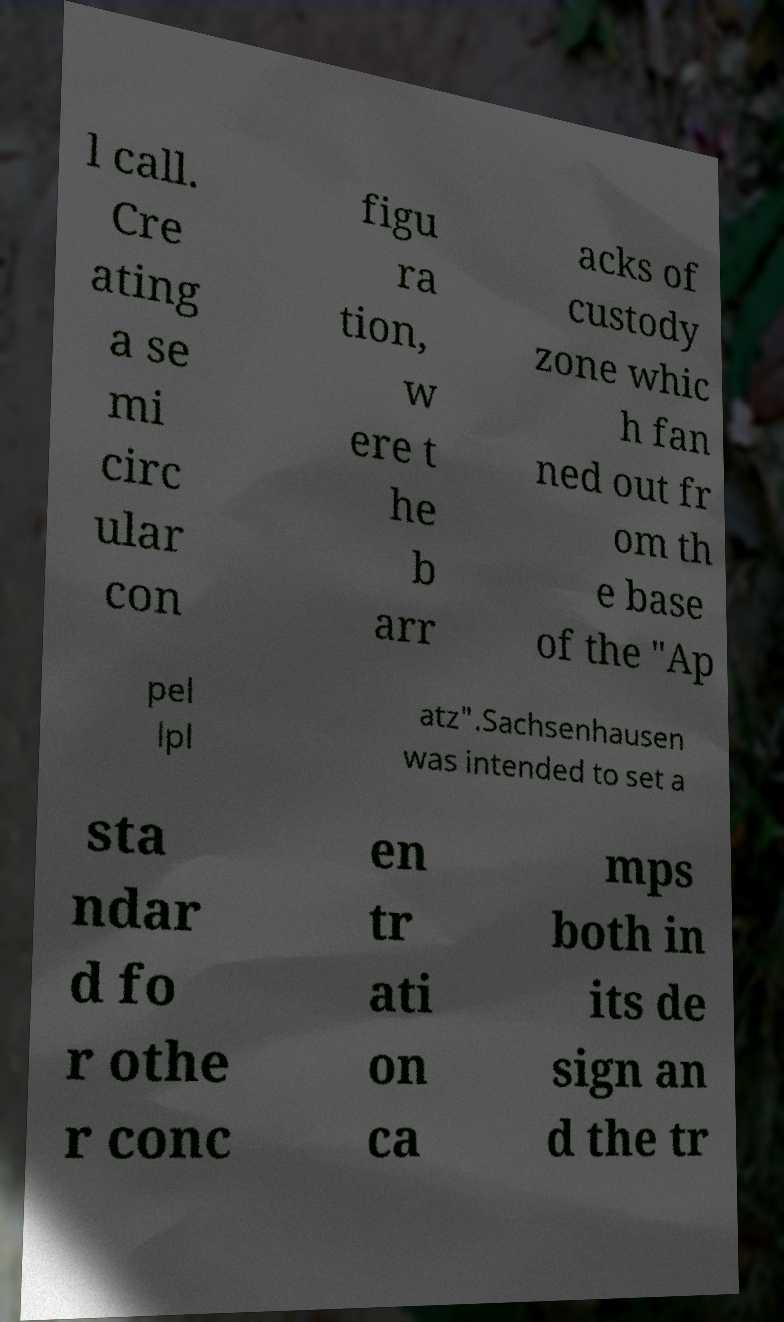There's text embedded in this image that I need extracted. Can you transcribe it verbatim? l call. Cre ating a se mi circ ular con figu ra tion, w ere t he b arr acks of custody zone whic h fan ned out fr om th e base of the "Ap pel lpl atz".Sachsenhausen was intended to set a sta ndar d fo r othe r conc en tr ati on ca mps both in its de sign an d the tr 